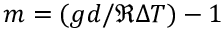Convert formula to latex. <formula><loc_0><loc_0><loc_500><loc_500>m = ( g d / \mathfrak { R } \Delta T ) - 1</formula> 